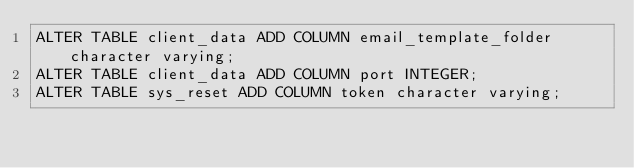Convert code to text. <code><loc_0><loc_0><loc_500><loc_500><_SQL_>ALTER TABLE client_data ADD COLUMN email_template_folder character varying;
ALTER TABLE client_data ADD COLUMN port INTEGER;
ALTER TABLE sys_reset ADD COLUMN token character varying;
</code> 